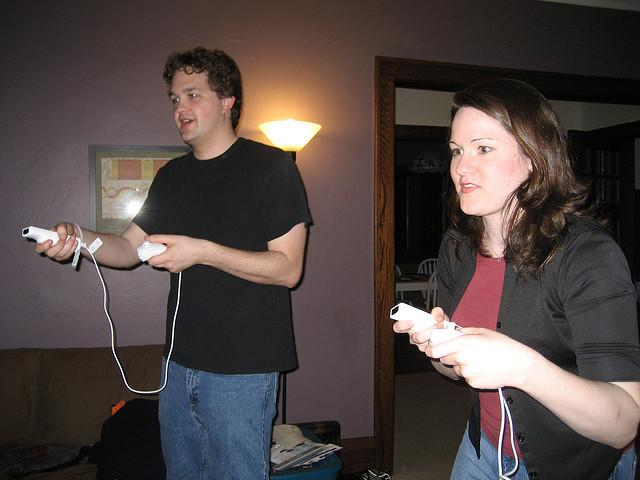Are the guy and girl holding gaming controllers?
Concise answer only. Yes. What is the only clothing item that does not match?
Quick response, please. Red shirt. Does the girl look like she is concentrating?
Be succinct. Yes. 